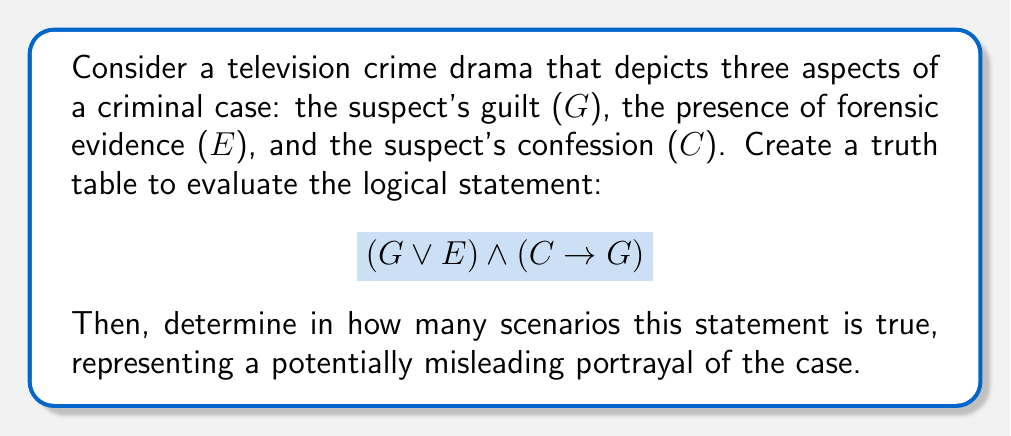Give your solution to this math problem. To solve this problem, we need to create a truth table and evaluate the given logical expression. Let's break it down step by step:

1. Identify the variables:
   G: Suspect's guilt
   E: Presence of forensic evidence
   C: Suspect's confession

2. Create the truth table with all possible combinations:

   | G | E | C | G ∨ E | C → G | (G ∨ E) ∧ (C → G) |
   |---|---|---|-------|-------|-------------------|
   | T | T | T |   T   |   T   |         T         |
   | T | T | F |   T   |   T   |         T         |
   | T | F | T |   T   |   T   |         T         |
   | T | F | F |   T   |   T   |         T         |
   | F | T | T |   T   |   F   |         F         |
   | F | T | F |   T   |   T   |         T         |
   | F | F | T |   F   |   F   |         F         |
   | F | F | F |   F   |   T   |         F         |

3. Evaluate each component:
   - $G \lor E$: True when either G or E (or both) are true
   - $C \rightarrow G$: False only when C is true and G is false

4. Combine the components:
   $(G \lor E) \land (C \rightarrow G)$: True only when both components are true

5. Count the number of true outcomes:
   There are 5 rows where the final result is true.

This truth table represents potentially misleading portrayals because it includes scenarios where:
- The suspect is guilty without evidence or confession
- Evidence exists, but the suspect is not guilty
- A confession occurs, but the suspect is not guilty (although this scenario results in a false outcome)

These scenarios highlight how media representations of crime can oversimplify or misrepresent the complexities of real criminal cases.
Answer: The logical statement $(G \lor E) \land (C \rightarrow G)$ is true in 5 out of 8 possible scenarios, potentially representing misleading portrayals of the criminal case in a television crime drama. 